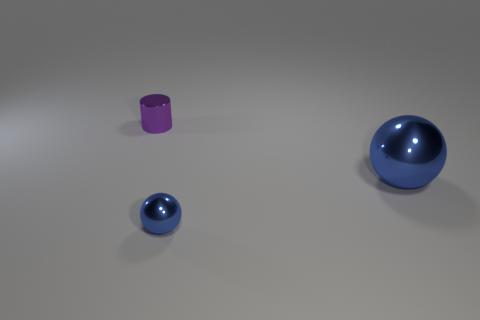There is a ball left of the large ball; what size is it?
Provide a short and direct response. Small. Is the number of blue balls that are in front of the big blue object the same as the number of shiny cylinders that are in front of the tiny cylinder?
Offer a very short reply. No. The tiny thing on the right side of the small thing left of the blue shiny ball that is in front of the big object is what color?
Your response must be concise. Blue. How many things are to the left of the tiny blue metal object and on the right side of the small blue thing?
Ensure brevity in your answer.  0. There is a big metallic ball that is to the right of the tiny sphere; is it the same color as the small metal object that is to the right of the purple shiny cylinder?
Your answer should be compact. Yes. Is there any other thing that has the same material as the small sphere?
Make the answer very short. Yes. What size is the other blue thing that is the same shape as the big blue object?
Your answer should be compact. Small. There is a big shiny object; are there any metallic spheres right of it?
Your response must be concise. No. Are there the same number of tiny blue balls to the left of the tiny purple object and small spheres?
Keep it short and to the point. No. Are there any metal spheres on the right side of the tiny object that is in front of the tiny object behind the big thing?
Offer a very short reply. Yes. 